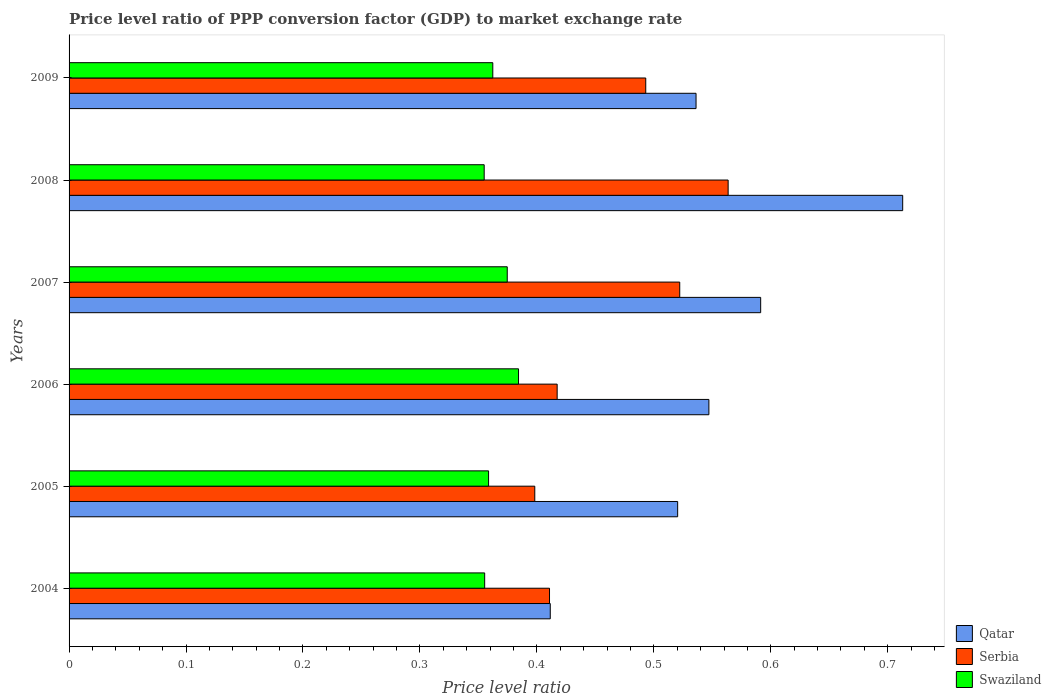How many different coloured bars are there?
Make the answer very short. 3. Are the number of bars per tick equal to the number of legend labels?
Offer a terse response. Yes. How many bars are there on the 6th tick from the bottom?
Make the answer very short. 3. What is the price level ratio in Serbia in 2009?
Keep it short and to the point. 0.49. Across all years, what is the maximum price level ratio in Swaziland?
Ensure brevity in your answer.  0.38. Across all years, what is the minimum price level ratio in Serbia?
Provide a succinct answer. 0.4. In which year was the price level ratio in Qatar maximum?
Provide a succinct answer. 2008. In which year was the price level ratio in Swaziland minimum?
Make the answer very short. 2008. What is the total price level ratio in Swaziland in the graph?
Provide a succinct answer. 2.19. What is the difference between the price level ratio in Swaziland in 2007 and that in 2008?
Your answer should be compact. 0.02. What is the difference between the price level ratio in Swaziland in 2004 and the price level ratio in Serbia in 2008?
Offer a very short reply. -0.21. What is the average price level ratio in Serbia per year?
Your answer should be compact. 0.47. In the year 2005, what is the difference between the price level ratio in Qatar and price level ratio in Serbia?
Your response must be concise. 0.12. What is the ratio of the price level ratio in Qatar in 2005 to that in 2008?
Make the answer very short. 0.73. What is the difference between the highest and the second highest price level ratio in Serbia?
Your answer should be very brief. 0.04. What is the difference between the highest and the lowest price level ratio in Qatar?
Make the answer very short. 0.3. What does the 3rd bar from the top in 2007 represents?
Provide a succinct answer. Qatar. What does the 3rd bar from the bottom in 2008 represents?
Your answer should be compact. Swaziland. How many bars are there?
Make the answer very short. 18. How many years are there in the graph?
Offer a very short reply. 6. What is the difference between two consecutive major ticks on the X-axis?
Offer a terse response. 0.1. Are the values on the major ticks of X-axis written in scientific E-notation?
Make the answer very short. No. Does the graph contain any zero values?
Your response must be concise. No. How many legend labels are there?
Make the answer very short. 3. How are the legend labels stacked?
Offer a terse response. Vertical. What is the title of the graph?
Your answer should be very brief. Price level ratio of PPP conversion factor (GDP) to market exchange rate. What is the label or title of the X-axis?
Provide a succinct answer. Price level ratio. What is the Price level ratio in Qatar in 2004?
Your answer should be very brief. 0.41. What is the Price level ratio in Serbia in 2004?
Make the answer very short. 0.41. What is the Price level ratio in Swaziland in 2004?
Ensure brevity in your answer.  0.36. What is the Price level ratio of Qatar in 2005?
Ensure brevity in your answer.  0.52. What is the Price level ratio of Serbia in 2005?
Ensure brevity in your answer.  0.4. What is the Price level ratio in Swaziland in 2005?
Offer a terse response. 0.36. What is the Price level ratio in Qatar in 2006?
Provide a succinct answer. 0.55. What is the Price level ratio of Serbia in 2006?
Offer a terse response. 0.42. What is the Price level ratio of Swaziland in 2006?
Offer a very short reply. 0.38. What is the Price level ratio of Qatar in 2007?
Your response must be concise. 0.59. What is the Price level ratio in Serbia in 2007?
Your response must be concise. 0.52. What is the Price level ratio of Swaziland in 2007?
Offer a terse response. 0.37. What is the Price level ratio in Qatar in 2008?
Your response must be concise. 0.71. What is the Price level ratio in Serbia in 2008?
Ensure brevity in your answer.  0.56. What is the Price level ratio in Swaziland in 2008?
Provide a succinct answer. 0.35. What is the Price level ratio of Qatar in 2009?
Your response must be concise. 0.54. What is the Price level ratio of Serbia in 2009?
Keep it short and to the point. 0.49. What is the Price level ratio in Swaziland in 2009?
Offer a terse response. 0.36. Across all years, what is the maximum Price level ratio of Qatar?
Your answer should be compact. 0.71. Across all years, what is the maximum Price level ratio of Serbia?
Make the answer very short. 0.56. Across all years, what is the maximum Price level ratio of Swaziland?
Provide a succinct answer. 0.38. Across all years, what is the minimum Price level ratio of Qatar?
Offer a very short reply. 0.41. Across all years, what is the minimum Price level ratio in Serbia?
Provide a short and direct response. 0.4. Across all years, what is the minimum Price level ratio of Swaziland?
Offer a terse response. 0.35. What is the total Price level ratio of Qatar in the graph?
Keep it short and to the point. 3.32. What is the total Price level ratio of Serbia in the graph?
Provide a short and direct response. 2.81. What is the total Price level ratio in Swaziland in the graph?
Make the answer very short. 2.19. What is the difference between the Price level ratio of Qatar in 2004 and that in 2005?
Your answer should be very brief. -0.11. What is the difference between the Price level ratio in Serbia in 2004 and that in 2005?
Ensure brevity in your answer.  0.01. What is the difference between the Price level ratio in Swaziland in 2004 and that in 2005?
Your answer should be very brief. -0. What is the difference between the Price level ratio in Qatar in 2004 and that in 2006?
Your answer should be compact. -0.14. What is the difference between the Price level ratio of Serbia in 2004 and that in 2006?
Ensure brevity in your answer.  -0.01. What is the difference between the Price level ratio in Swaziland in 2004 and that in 2006?
Your response must be concise. -0.03. What is the difference between the Price level ratio of Qatar in 2004 and that in 2007?
Make the answer very short. -0.18. What is the difference between the Price level ratio in Serbia in 2004 and that in 2007?
Give a very brief answer. -0.11. What is the difference between the Price level ratio of Swaziland in 2004 and that in 2007?
Give a very brief answer. -0.02. What is the difference between the Price level ratio of Qatar in 2004 and that in 2008?
Your answer should be compact. -0.3. What is the difference between the Price level ratio in Serbia in 2004 and that in 2008?
Make the answer very short. -0.15. What is the difference between the Price level ratio of Qatar in 2004 and that in 2009?
Give a very brief answer. -0.12. What is the difference between the Price level ratio of Serbia in 2004 and that in 2009?
Your answer should be very brief. -0.08. What is the difference between the Price level ratio in Swaziland in 2004 and that in 2009?
Provide a short and direct response. -0.01. What is the difference between the Price level ratio in Qatar in 2005 and that in 2006?
Ensure brevity in your answer.  -0.03. What is the difference between the Price level ratio in Serbia in 2005 and that in 2006?
Your answer should be very brief. -0.02. What is the difference between the Price level ratio of Swaziland in 2005 and that in 2006?
Your answer should be compact. -0.03. What is the difference between the Price level ratio of Qatar in 2005 and that in 2007?
Give a very brief answer. -0.07. What is the difference between the Price level ratio of Serbia in 2005 and that in 2007?
Your response must be concise. -0.12. What is the difference between the Price level ratio in Swaziland in 2005 and that in 2007?
Keep it short and to the point. -0.02. What is the difference between the Price level ratio in Qatar in 2005 and that in 2008?
Your response must be concise. -0.19. What is the difference between the Price level ratio of Serbia in 2005 and that in 2008?
Offer a very short reply. -0.17. What is the difference between the Price level ratio in Swaziland in 2005 and that in 2008?
Provide a succinct answer. 0. What is the difference between the Price level ratio in Qatar in 2005 and that in 2009?
Your answer should be compact. -0.02. What is the difference between the Price level ratio in Serbia in 2005 and that in 2009?
Offer a very short reply. -0.09. What is the difference between the Price level ratio of Swaziland in 2005 and that in 2009?
Make the answer very short. -0. What is the difference between the Price level ratio in Qatar in 2006 and that in 2007?
Keep it short and to the point. -0.04. What is the difference between the Price level ratio of Serbia in 2006 and that in 2007?
Your response must be concise. -0.1. What is the difference between the Price level ratio of Swaziland in 2006 and that in 2007?
Your response must be concise. 0.01. What is the difference between the Price level ratio in Qatar in 2006 and that in 2008?
Provide a succinct answer. -0.17. What is the difference between the Price level ratio of Serbia in 2006 and that in 2008?
Your response must be concise. -0.15. What is the difference between the Price level ratio in Swaziland in 2006 and that in 2008?
Your answer should be compact. 0.03. What is the difference between the Price level ratio in Qatar in 2006 and that in 2009?
Ensure brevity in your answer.  0.01. What is the difference between the Price level ratio in Serbia in 2006 and that in 2009?
Provide a short and direct response. -0.08. What is the difference between the Price level ratio of Swaziland in 2006 and that in 2009?
Give a very brief answer. 0.02. What is the difference between the Price level ratio in Qatar in 2007 and that in 2008?
Provide a succinct answer. -0.12. What is the difference between the Price level ratio in Serbia in 2007 and that in 2008?
Ensure brevity in your answer.  -0.04. What is the difference between the Price level ratio in Swaziland in 2007 and that in 2008?
Make the answer very short. 0.02. What is the difference between the Price level ratio of Qatar in 2007 and that in 2009?
Your answer should be compact. 0.06. What is the difference between the Price level ratio in Serbia in 2007 and that in 2009?
Offer a very short reply. 0.03. What is the difference between the Price level ratio in Swaziland in 2007 and that in 2009?
Provide a short and direct response. 0.01. What is the difference between the Price level ratio of Qatar in 2008 and that in 2009?
Ensure brevity in your answer.  0.18. What is the difference between the Price level ratio in Serbia in 2008 and that in 2009?
Offer a terse response. 0.07. What is the difference between the Price level ratio in Swaziland in 2008 and that in 2009?
Give a very brief answer. -0.01. What is the difference between the Price level ratio of Qatar in 2004 and the Price level ratio of Serbia in 2005?
Your answer should be compact. 0.01. What is the difference between the Price level ratio in Qatar in 2004 and the Price level ratio in Swaziland in 2005?
Your answer should be very brief. 0.05. What is the difference between the Price level ratio of Serbia in 2004 and the Price level ratio of Swaziland in 2005?
Your answer should be compact. 0.05. What is the difference between the Price level ratio of Qatar in 2004 and the Price level ratio of Serbia in 2006?
Keep it short and to the point. -0.01. What is the difference between the Price level ratio in Qatar in 2004 and the Price level ratio in Swaziland in 2006?
Provide a succinct answer. 0.03. What is the difference between the Price level ratio in Serbia in 2004 and the Price level ratio in Swaziland in 2006?
Offer a very short reply. 0.03. What is the difference between the Price level ratio in Qatar in 2004 and the Price level ratio in Serbia in 2007?
Offer a terse response. -0.11. What is the difference between the Price level ratio of Qatar in 2004 and the Price level ratio of Swaziland in 2007?
Provide a succinct answer. 0.04. What is the difference between the Price level ratio of Serbia in 2004 and the Price level ratio of Swaziland in 2007?
Ensure brevity in your answer.  0.04. What is the difference between the Price level ratio in Qatar in 2004 and the Price level ratio in Serbia in 2008?
Keep it short and to the point. -0.15. What is the difference between the Price level ratio of Qatar in 2004 and the Price level ratio of Swaziland in 2008?
Provide a short and direct response. 0.06. What is the difference between the Price level ratio of Serbia in 2004 and the Price level ratio of Swaziland in 2008?
Your answer should be compact. 0.06. What is the difference between the Price level ratio in Qatar in 2004 and the Price level ratio in Serbia in 2009?
Make the answer very short. -0.08. What is the difference between the Price level ratio in Qatar in 2004 and the Price level ratio in Swaziland in 2009?
Offer a very short reply. 0.05. What is the difference between the Price level ratio in Serbia in 2004 and the Price level ratio in Swaziland in 2009?
Give a very brief answer. 0.05. What is the difference between the Price level ratio of Qatar in 2005 and the Price level ratio of Serbia in 2006?
Ensure brevity in your answer.  0.1. What is the difference between the Price level ratio in Qatar in 2005 and the Price level ratio in Swaziland in 2006?
Ensure brevity in your answer.  0.14. What is the difference between the Price level ratio of Serbia in 2005 and the Price level ratio of Swaziland in 2006?
Offer a very short reply. 0.01. What is the difference between the Price level ratio of Qatar in 2005 and the Price level ratio of Serbia in 2007?
Provide a short and direct response. -0. What is the difference between the Price level ratio in Qatar in 2005 and the Price level ratio in Swaziland in 2007?
Your answer should be very brief. 0.15. What is the difference between the Price level ratio of Serbia in 2005 and the Price level ratio of Swaziland in 2007?
Give a very brief answer. 0.02. What is the difference between the Price level ratio of Qatar in 2005 and the Price level ratio of Serbia in 2008?
Your answer should be very brief. -0.04. What is the difference between the Price level ratio in Qatar in 2005 and the Price level ratio in Swaziland in 2008?
Provide a succinct answer. 0.17. What is the difference between the Price level ratio of Serbia in 2005 and the Price level ratio of Swaziland in 2008?
Give a very brief answer. 0.04. What is the difference between the Price level ratio in Qatar in 2005 and the Price level ratio in Serbia in 2009?
Offer a very short reply. 0.03. What is the difference between the Price level ratio of Qatar in 2005 and the Price level ratio of Swaziland in 2009?
Your answer should be very brief. 0.16. What is the difference between the Price level ratio in Serbia in 2005 and the Price level ratio in Swaziland in 2009?
Provide a succinct answer. 0.04. What is the difference between the Price level ratio in Qatar in 2006 and the Price level ratio in Serbia in 2007?
Provide a succinct answer. 0.02. What is the difference between the Price level ratio in Qatar in 2006 and the Price level ratio in Swaziland in 2007?
Offer a very short reply. 0.17. What is the difference between the Price level ratio in Serbia in 2006 and the Price level ratio in Swaziland in 2007?
Offer a terse response. 0.04. What is the difference between the Price level ratio of Qatar in 2006 and the Price level ratio of Serbia in 2008?
Your response must be concise. -0.02. What is the difference between the Price level ratio of Qatar in 2006 and the Price level ratio of Swaziland in 2008?
Your answer should be compact. 0.19. What is the difference between the Price level ratio of Serbia in 2006 and the Price level ratio of Swaziland in 2008?
Your answer should be very brief. 0.06. What is the difference between the Price level ratio of Qatar in 2006 and the Price level ratio of Serbia in 2009?
Make the answer very short. 0.05. What is the difference between the Price level ratio of Qatar in 2006 and the Price level ratio of Swaziland in 2009?
Offer a very short reply. 0.18. What is the difference between the Price level ratio in Serbia in 2006 and the Price level ratio in Swaziland in 2009?
Give a very brief answer. 0.06. What is the difference between the Price level ratio in Qatar in 2007 and the Price level ratio in Serbia in 2008?
Give a very brief answer. 0.03. What is the difference between the Price level ratio in Qatar in 2007 and the Price level ratio in Swaziland in 2008?
Offer a very short reply. 0.24. What is the difference between the Price level ratio of Serbia in 2007 and the Price level ratio of Swaziland in 2008?
Keep it short and to the point. 0.17. What is the difference between the Price level ratio in Qatar in 2007 and the Price level ratio in Serbia in 2009?
Offer a very short reply. 0.1. What is the difference between the Price level ratio of Qatar in 2007 and the Price level ratio of Swaziland in 2009?
Keep it short and to the point. 0.23. What is the difference between the Price level ratio in Serbia in 2007 and the Price level ratio in Swaziland in 2009?
Your answer should be compact. 0.16. What is the difference between the Price level ratio of Qatar in 2008 and the Price level ratio of Serbia in 2009?
Provide a short and direct response. 0.22. What is the difference between the Price level ratio of Qatar in 2008 and the Price level ratio of Swaziland in 2009?
Offer a very short reply. 0.35. What is the difference between the Price level ratio in Serbia in 2008 and the Price level ratio in Swaziland in 2009?
Your answer should be compact. 0.2. What is the average Price level ratio of Qatar per year?
Provide a succinct answer. 0.55. What is the average Price level ratio in Serbia per year?
Provide a succinct answer. 0.47. What is the average Price level ratio in Swaziland per year?
Provide a short and direct response. 0.36. In the year 2004, what is the difference between the Price level ratio in Qatar and Price level ratio in Serbia?
Your answer should be very brief. 0. In the year 2004, what is the difference between the Price level ratio in Qatar and Price level ratio in Swaziland?
Offer a terse response. 0.06. In the year 2004, what is the difference between the Price level ratio of Serbia and Price level ratio of Swaziland?
Offer a terse response. 0.06. In the year 2005, what is the difference between the Price level ratio of Qatar and Price level ratio of Serbia?
Ensure brevity in your answer.  0.12. In the year 2005, what is the difference between the Price level ratio in Qatar and Price level ratio in Swaziland?
Your answer should be very brief. 0.16. In the year 2005, what is the difference between the Price level ratio in Serbia and Price level ratio in Swaziland?
Your response must be concise. 0.04. In the year 2006, what is the difference between the Price level ratio of Qatar and Price level ratio of Serbia?
Keep it short and to the point. 0.13. In the year 2006, what is the difference between the Price level ratio of Qatar and Price level ratio of Swaziland?
Offer a very short reply. 0.16. In the year 2006, what is the difference between the Price level ratio in Serbia and Price level ratio in Swaziland?
Provide a short and direct response. 0.03. In the year 2007, what is the difference between the Price level ratio of Qatar and Price level ratio of Serbia?
Offer a very short reply. 0.07. In the year 2007, what is the difference between the Price level ratio of Qatar and Price level ratio of Swaziland?
Your answer should be compact. 0.22. In the year 2007, what is the difference between the Price level ratio of Serbia and Price level ratio of Swaziland?
Make the answer very short. 0.15. In the year 2008, what is the difference between the Price level ratio in Qatar and Price level ratio in Serbia?
Ensure brevity in your answer.  0.15. In the year 2008, what is the difference between the Price level ratio of Qatar and Price level ratio of Swaziland?
Give a very brief answer. 0.36. In the year 2008, what is the difference between the Price level ratio in Serbia and Price level ratio in Swaziland?
Give a very brief answer. 0.21. In the year 2009, what is the difference between the Price level ratio of Qatar and Price level ratio of Serbia?
Your response must be concise. 0.04. In the year 2009, what is the difference between the Price level ratio of Qatar and Price level ratio of Swaziland?
Provide a short and direct response. 0.17. In the year 2009, what is the difference between the Price level ratio in Serbia and Price level ratio in Swaziland?
Your answer should be compact. 0.13. What is the ratio of the Price level ratio in Qatar in 2004 to that in 2005?
Offer a terse response. 0.79. What is the ratio of the Price level ratio in Serbia in 2004 to that in 2005?
Offer a very short reply. 1.03. What is the ratio of the Price level ratio in Swaziland in 2004 to that in 2005?
Your response must be concise. 0.99. What is the ratio of the Price level ratio of Qatar in 2004 to that in 2006?
Make the answer very short. 0.75. What is the ratio of the Price level ratio of Serbia in 2004 to that in 2006?
Make the answer very short. 0.98. What is the ratio of the Price level ratio of Swaziland in 2004 to that in 2006?
Your response must be concise. 0.92. What is the ratio of the Price level ratio of Qatar in 2004 to that in 2007?
Offer a terse response. 0.7. What is the ratio of the Price level ratio of Serbia in 2004 to that in 2007?
Offer a terse response. 0.79. What is the ratio of the Price level ratio in Swaziland in 2004 to that in 2007?
Ensure brevity in your answer.  0.95. What is the ratio of the Price level ratio of Qatar in 2004 to that in 2008?
Your answer should be very brief. 0.58. What is the ratio of the Price level ratio in Serbia in 2004 to that in 2008?
Keep it short and to the point. 0.73. What is the ratio of the Price level ratio of Swaziland in 2004 to that in 2008?
Offer a terse response. 1. What is the ratio of the Price level ratio in Qatar in 2004 to that in 2009?
Provide a short and direct response. 0.77. What is the ratio of the Price level ratio in Serbia in 2004 to that in 2009?
Give a very brief answer. 0.83. What is the ratio of the Price level ratio of Swaziland in 2004 to that in 2009?
Provide a succinct answer. 0.98. What is the ratio of the Price level ratio in Qatar in 2005 to that in 2006?
Give a very brief answer. 0.95. What is the ratio of the Price level ratio of Serbia in 2005 to that in 2006?
Ensure brevity in your answer.  0.95. What is the ratio of the Price level ratio in Swaziland in 2005 to that in 2006?
Make the answer very short. 0.93. What is the ratio of the Price level ratio of Qatar in 2005 to that in 2007?
Ensure brevity in your answer.  0.88. What is the ratio of the Price level ratio of Serbia in 2005 to that in 2007?
Your response must be concise. 0.76. What is the ratio of the Price level ratio of Swaziland in 2005 to that in 2007?
Make the answer very short. 0.96. What is the ratio of the Price level ratio in Qatar in 2005 to that in 2008?
Your answer should be compact. 0.73. What is the ratio of the Price level ratio of Serbia in 2005 to that in 2008?
Make the answer very short. 0.71. What is the ratio of the Price level ratio of Swaziland in 2005 to that in 2008?
Keep it short and to the point. 1.01. What is the ratio of the Price level ratio of Qatar in 2005 to that in 2009?
Give a very brief answer. 0.97. What is the ratio of the Price level ratio of Serbia in 2005 to that in 2009?
Your response must be concise. 0.81. What is the ratio of the Price level ratio in Qatar in 2006 to that in 2007?
Give a very brief answer. 0.93. What is the ratio of the Price level ratio in Serbia in 2006 to that in 2007?
Provide a succinct answer. 0.8. What is the ratio of the Price level ratio in Swaziland in 2006 to that in 2007?
Provide a short and direct response. 1.03. What is the ratio of the Price level ratio in Qatar in 2006 to that in 2008?
Provide a short and direct response. 0.77. What is the ratio of the Price level ratio in Serbia in 2006 to that in 2008?
Your answer should be very brief. 0.74. What is the ratio of the Price level ratio in Swaziland in 2006 to that in 2008?
Offer a very short reply. 1.08. What is the ratio of the Price level ratio of Qatar in 2006 to that in 2009?
Ensure brevity in your answer.  1.02. What is the ratio of the Price level ratio in Serbia in 2006 to that in 2009?
Keep it short and to the point. 0.85. What is the ratio of the Price level ratio in Swaziland in 2006 to that in 2009?
Your response must be concise. 1.06. What is the ratio of the Price level ratio of Qatar in 2007 to that in 2008?
Give a very brief answer. 0.83. What is the ratio of the Price level ratio of Serbia in 2007 to that in 2008?
Your answer should be very brief. 0.93. What is the ratio of the Price level ratio in Swaziland in 2007 to that in 2008?
Provide a short and direct response. 1.06. What is the ratio of the Price level ratio of Qatar in 2007 to that in 2009?
Your response must be concise. 1.1. What is the ratio of the Price level ratio in Serbia in 2007 to that in 2009?
Keep it short and to the point. 1.06. What is the ratio of the Price level ratio of Swaziland in 2007 to that in 2009?
Keep it short and to the point. 1.03. What is the ratio of the Price level ratio in Qatar in 2008 to that in 2009?
Your answer should be compact. 1.33. What is the ratio of the Price level ratio in Swaziland in 2008 to that in 2009?
Offer a terse response. 0.98. What is the difference between the highest and the second highest Price level ratio in Qatar?
Ensure brevity in your answer.  0.12. What is the difference between the highest and the second highest Price level ratio in Serbia?
Ensure brevity in your answer.  0.04. What is the difference between the highest and the second highest Price level ratio of Swaziland?
Offer a very short reply. 0.01. What is the difference between the highest and the lowest Price level ratio in Qatar?
Give a very brief answer. 0.3. What is the difference between the highest and the lowest Price level ratio in Serbia?
Your answer should be compact. 0.17. What is the difference between the highest and the lowest Price level ratio of Swaziland?
Provide a succinct answer. 0.03. 